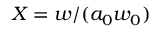Convert formula to latex. <formula><loc_0><loc_0><loc_500><loc_500>X = w / ( a _ { 0 } w _ { 0 } )</formula> 